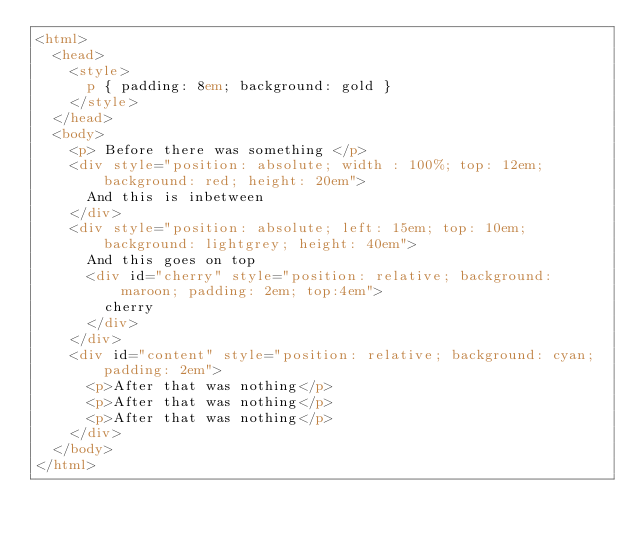<code> <loc_0><loc_0><loc_500><loc_500><_HTML_><html>
  <head>
    <style>
      p { padding: 8em; background: gold }
    </style>
  </head>
  <body>
    <p> Before there was something </p>
    <div style="position: absolute; width : 100%; top: 12em; background: red; height: 20em">
      And this is inbetween
    </div>
    <div style="position: absolute; left: 15em; top: 10em; background: lightgrey; height: 40em">
      And this goes on top
      <div id="cherry" style="position: relative; background: maroon; padding: 2em; top:4em">
        cherry
      </div>
    </div>
    <div id="content" style="position: relative; background: cyan; padding: 2em">
      <p>After that was nothing</p>
      <p>After that was nothing</p>
      <p>After that was nothing</p>
    </div>
  </body>
</html>
</code> 